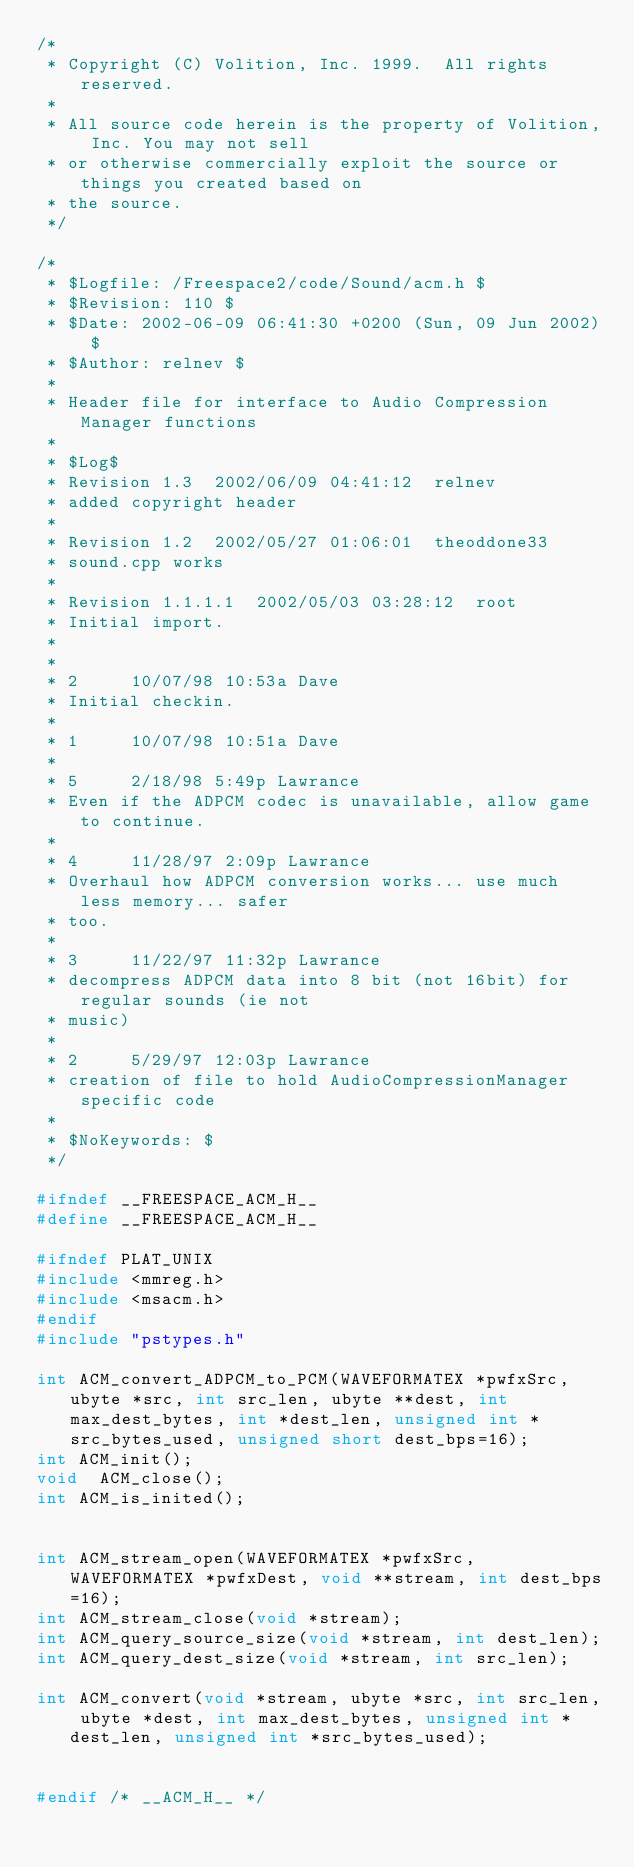Convert code to text. <code><loc_0><loc_0><loc_500><loc_500><_C_>/*
 * Copyright (C) Volition, Inc. 1999.  All rights reserved.
 *
 * All source code herein is the property of Volition, Inc. You may not sell 
 * or otherwise commercially exploit the source or things you created based on
 * the source.
 */

/*
 * $Logfile: /Freespace2/code/Sound/acm.h $
 * $Revision: 110 $
 * $Date: 2002-06-09 06:41:30 +0200 (Sun, 09 Jun 2002) $
 * $Author: relnev $
 *
 * Header file for interface to Audio Compression Manager functions
 *
 * $Log$
 * Revision 1.3  2002/06/09 04:41:12  relnev
 * added copyright header
 *
 * Revision 1.2  2002/05/27 01:06:01  theoddone33
 * sound.cpp works
 *
 * Revision 1.1.1.1  2002/05/03 03:28:12  root
 * Initial import.
 *
 * 
 * 2     10/07/98 10:53a Dave
 * Initial checkin.
 * 
 * 1     10/07/98 10:51a Dave
 * 
 * 5     2/18/98 5:49p Lawrance
 * Even if the ADPCM codec is unavailable, allow game to continue.
 * 
 * 4     11/28/97 2:09p Lawrance
 * Overhaul how ADPCM conversion works... use much less memory... safer
 * too.
 * 
 * 3     11/22/97 11:32p Lawrance
 * decompress ADPCM data into 8 bit (not 16bit) for regular sounds (ie not
 * music)
 * 
 * 2     5/29/97 12:03p Lawrance
 * creation of file to hold AudioCompressionManager specific code
 *
 * $NoKeywords: $
 */

#ifndef __FREESPACE_ACM_H__
#define __FREESPACE_ACM_H__

#ifndef PLAT_UNIX
#include <mmreg.h>
#include <msacm.h>
#endif
#include "pstypes.h"

int	ACM_convert_ADPCM_to_PCM(WAVEFORMATEX *pwfxSrc, ubyte *src, int src_len, ubyte **dest, int max_dest_bytes, int *dest_len, unsigned int *src_bytes_used, unsigned short dest_bps=16);
int	ACM_init();
void	ACM_close();
int	ACM_is_inited();


int ACM_stream_open(WAVEFORMATEX *pwfxSrc, WAVEFORMATEX *pwfxDest, void **stream, int dest_bps=16);
int ACM_stream_close(void *stream);
int ACM_query_source_size(void *stream, int dest_len);
int ACM_query_dest_size(void *stream, int src_len);

int ACM_convert(void *stream, ubyte *src, int src_len, ubyte *dest, int max_dest_bytes, unsigned int *dest_len, unsigned int *src_bytes_used);


#endif /* __ACM_H__ */

</code> 